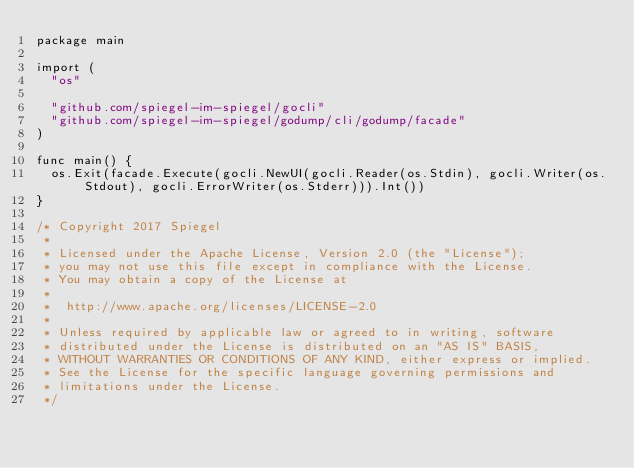Convert code to text. <code><loc_0><loc_0><loc_500><loc_500><_Go_>package main

import (
	"os"

	"github.com/spiegel-im-spiegel/gocli"
	"github.com/spiegel-im-spiegel/godump/cli/godump/facade"
)

func main() {
	os.Exit(facade.Execute(gocli.NewUI(gocli.Reader(os.Stdin), gocli.Writer(os.Stdout), gocli.ErrorWriter(os.Stderr))).Int())
}

/* Copyright 2017 Spiegel
 *
 * Licensed under the Apache License, Version 2.0 (the "License");
 * you may not use this file except in compliance with the License.
 * You may obtain a copy of the License at
 *
 * 	http://www.apache.org/licenses/LICENSE-2.0
 *
 * Unless required by applicable law or agreed to in writing, software
 * distributed under the License is distributed on an "AS IS" BASIS,
 * WITHOUT WARRANTIES OR CONDITIONS OF ANY KIND, either express or implied.
 * See the License for the specific language governing permissions and
 * limitations under the License.
 */
</code> 